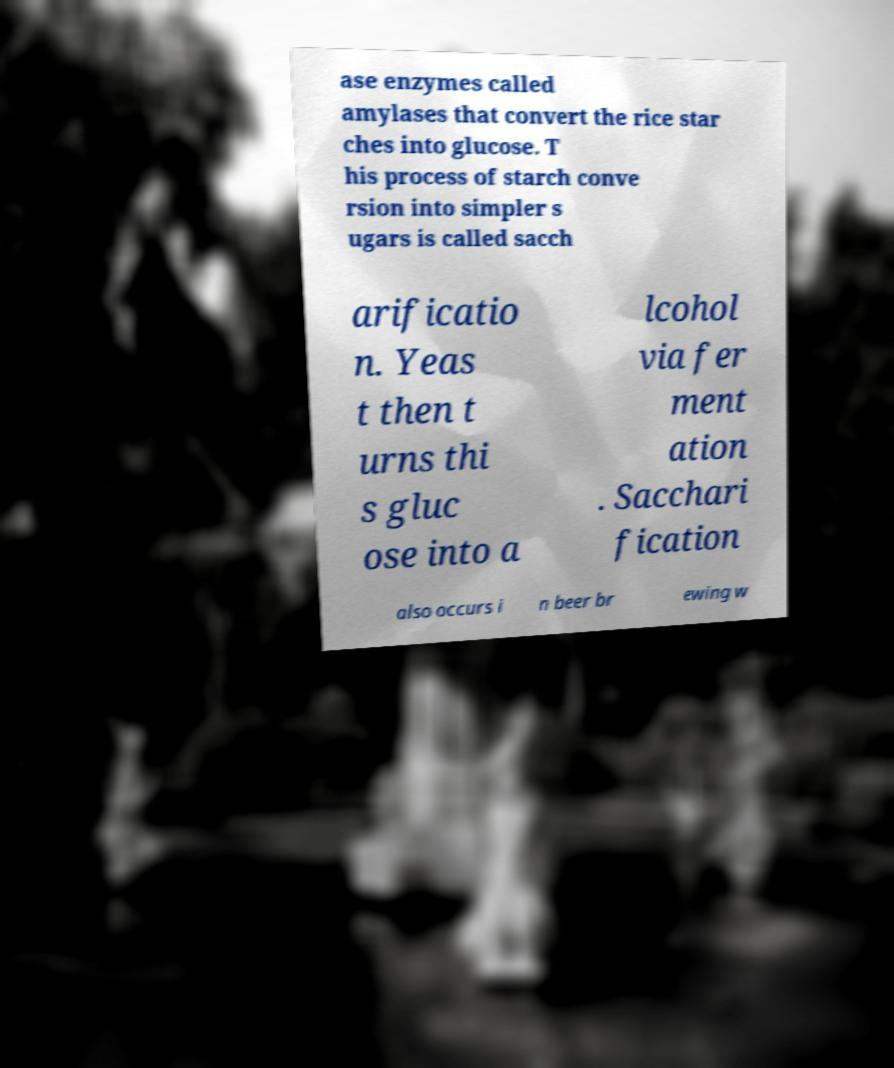I need the written content from this picture converted into text. Can you do that? ase enzymes called amylases that convert the rice star ches into glucose. T his process of starch conve rsion into simpler s ugars is called sacch arificatio n. Yeas t then t urns thi s gluc ose into a lcohol via fer ment ation . Sacchari fication also occurs i n beer br ewing w 